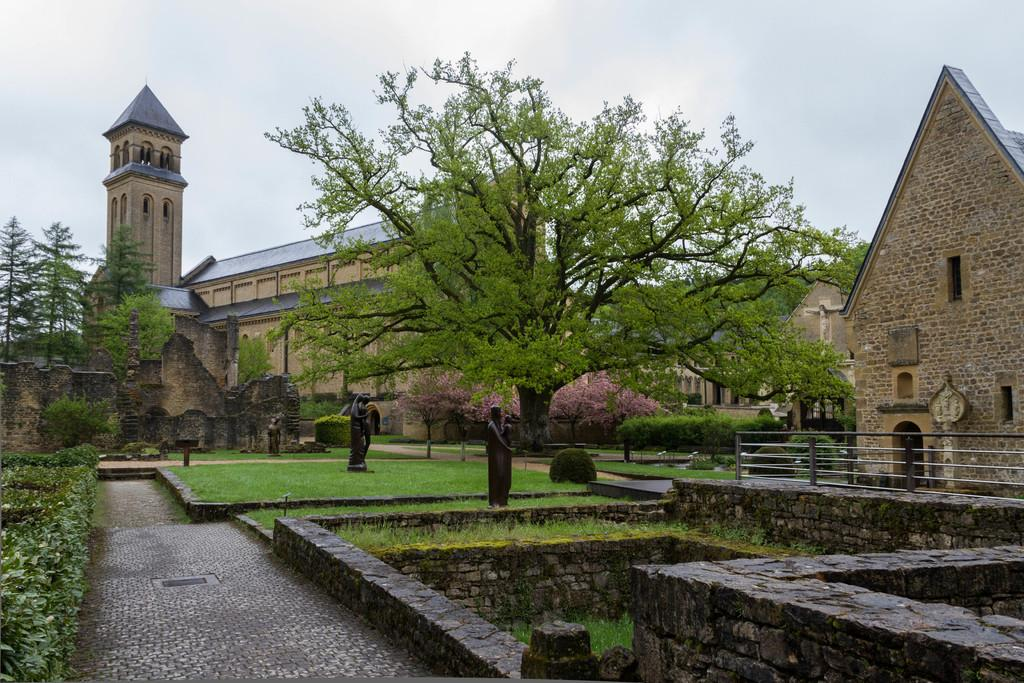What is located in the middle of the image? There are statues in the middle of the image. What type of vegetation can be seen in the image? There are trees in the image. What structures are visible in the background of the image? There are houses visible at the back side of the image. What is visible at the top of the image? The sky is visible at the top of the image. What type of barrier is present on the right side of the image? There is a stone wall on the right side of the image. What type of sheet is draped over the statues in the image? There is no sheet present in the image; the statues are not covered. What sound can be heard coming from the trees in the image? The image is static, so no sounds can be heard. 